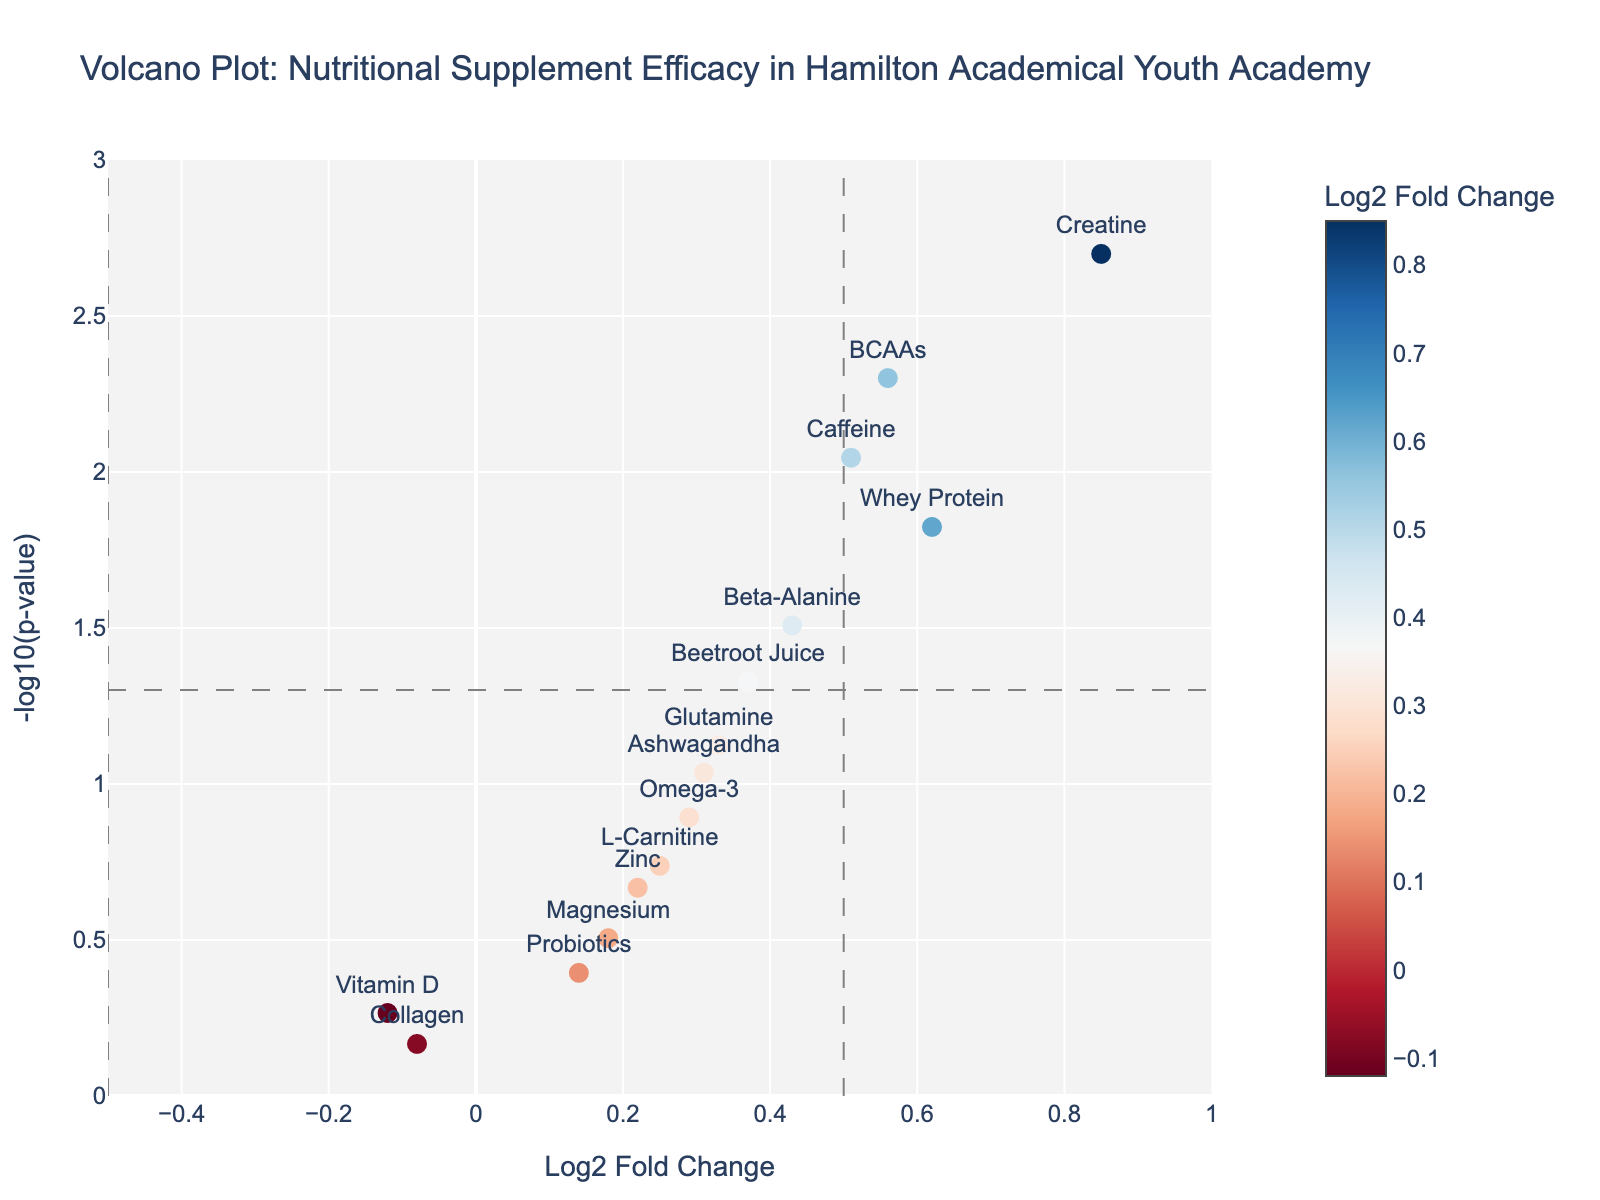What is the title of the volcano plot? The title is displayed at the top of the figure, providing a description of what the plot represents. Here, the title is "Volcano Plot: Nutritional Supplement Efficacy in Hamilton Academical Youth Academy."
Answer: Volcano Plot: Nutritional Supplement Efficacy in Hamilton Academical Youth Academy How many supplements have a log2 fold change greater than 0.5? Look at the x-axis (Log2 Fold Change) and count the number of data points to the right of the vertical line at x=0.5. Here, there are three such points: Creatine, BCAAs, and Caffeine.
Answer: 3 Which supplement has the highest -log10(p-value) and what is its value? Identify the data point that is the highest on the y-axis, which represents the -log10(p-value). The highest point corresponds to Creatine. Check the y-value for this point.
Answer: Creatine, 2.699 What is the log2 fold change of the supplement with the second smallest p-value? Sort the supplements by their p-value in ascending order. The second smallest p-value corresponds to BCAAs (p-value = 0.005). The log2 fold change for BCAAs is 0.56.
Answer: 0.56 Which supplement shows a decrease in physical attributes and is it statistically significant? Look for data points with negative log2 fold change (on the left side of x=0). Among these, check if any are above the significance threshold line (-log10(0.05) ~1.301). Collagen and Vitamin D have negative log2 fold changes but neither is statistically significant as they do not cross the threshold.
Answer: None How many supplements have a statistically significant impact on physical attributes? Determine which supplements are above the horizontal line at y = -log10(0.05) (significance threshold) and count them. These are Creatine, Whey Protein, Caffeine, and BCAAs.
Answer: 4 Compare the efficacy of Glutamine and Beetroot Juice in terms of log2 fold change and p-value. Glutamine has a log2 fold change of 0.33 and a p-value of 0.075. Beetroot Juice has a log2 fold change of 0.37 and a p-value of 0.047. Beetroot Juice has both a higher log2 fold change and a lower (more significant) p-value.
Answer: Beetroot Juice has higher efficacy What color gradient represents the log2 fold change in the plot? The color of the data points is based on their log2 fold change values. Typically, a colorscale like 'RdBu' is used where one color (e.g., blue) might represent lower values and another (e.g., red) higher values.
Answer: RdBu colorscale Which supplement closest to the vertical reference line at x=0.5 is statistically significant? Identify the statistically significant supplements (above the horizontal threshold line) and find the one closest to x=0.5. BCAAs (log2 fold change = 0.56) is closest to the line at x=0.5 and is statistically significant.
Answer: BCAAs Do any supplements show a statistically significant decrease in physical attributes? Look at the left side of the plot (negative log2 fold change values) and check if any points are above the horizontal significance line (-log10(p-value) = 1.301). None of the points with a negative log2 fold change are above this line.
Answer: No 